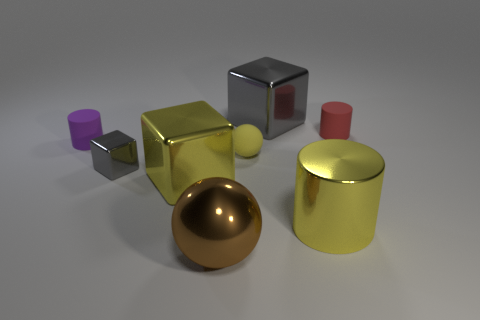Subtract all tiny cubes. How many cubes are left? 2 Add 2 small yellow blocks. How many objects exist? 10 Subtract all yellow spheres. How many gray cubes are left? 2 Subtract all yellow spheres. How many spheres are left? 1 Subtract all spheres. How many objects are left? 6 Subtract 2 balls. How many balls are left? 0 Subtract all yellow spheres. Subtract all red cylinders. How many spheres are left? 1 Subtract all large cubes. Subtract all big metallic objects. How many objects are left? 2 Add 3 yellow cylinders. How many yellow cylinders are left? 4 Add 2 big green rubber cylinders. How many big green rubber cylinders exist? 2 